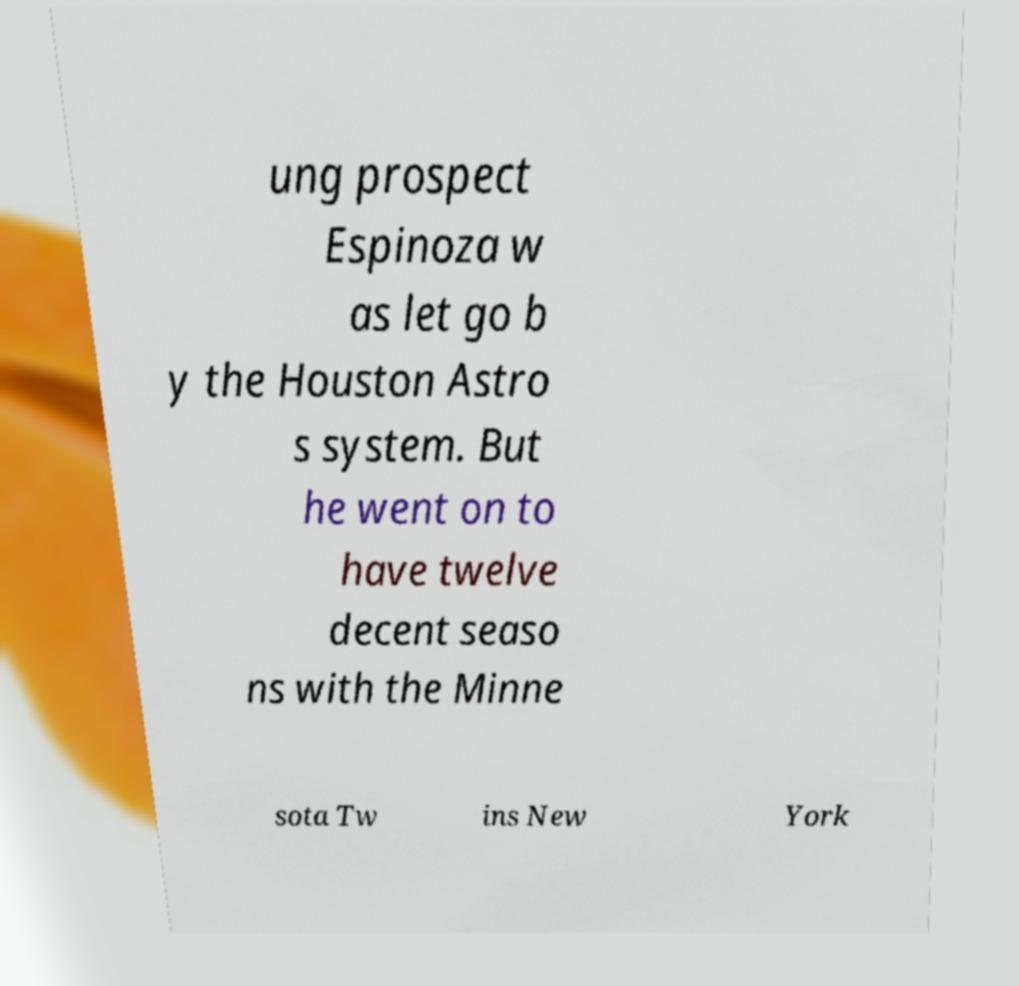What messages or text are displayed in this image? I need them in a readable, typed format. ung prospect Espinoza w as let go b y the Houston Astro s system. But he went on to have twelve decent seaso ns with the Minne sota Tw ins New York 